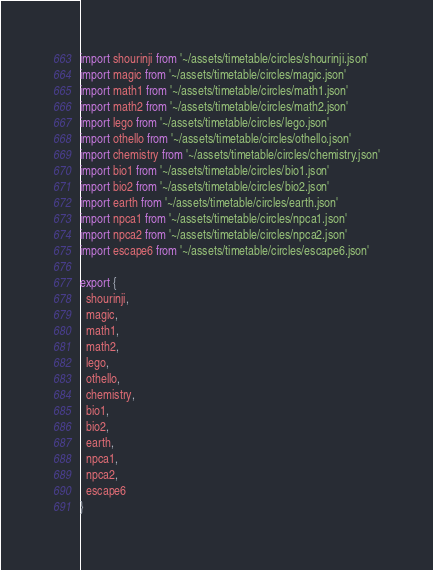Convert code to text. <code><loc_0><loc_0><loc_500><loc_500><_JavaScript_>import shourinji from '~/assets/timetable/circles/shourinji.json'
import magic from '~/assets/timetable/circles/magic.json'
import math1 from '~/assets/timetable/circles/math1.json'
import math2 from '~/assets/timetable/circles/math2.json'
import lego from '~/assets/timetable/circles/lego.json'
import othello from '~/assets/timetable/circles/othello.json'
import chemistry from '~/assets/timetable/circles/chemistry.json'
import bio1 from '~/assets/timetable/circles/bio1.json'
import bio2 from '~/assets/timetable/circles/bio2.json'
import earth from '~/assets/timetable/circles/earth.json'
import npca1 from '~/assets/timetable/circles/npca1.json'
import npca2 from '~/assets/timetable/circles/npca2.json'
import escape6 from '~/assets/timetable/circles/escape6.json'

export {
  shourinji,
  magic,
  math1,
  math2,
  lego,
  othello,
  chemistry,
  bio1,
  bio2,
  earth,
  npca1,
  npca2,
  escape6
}
</code> 